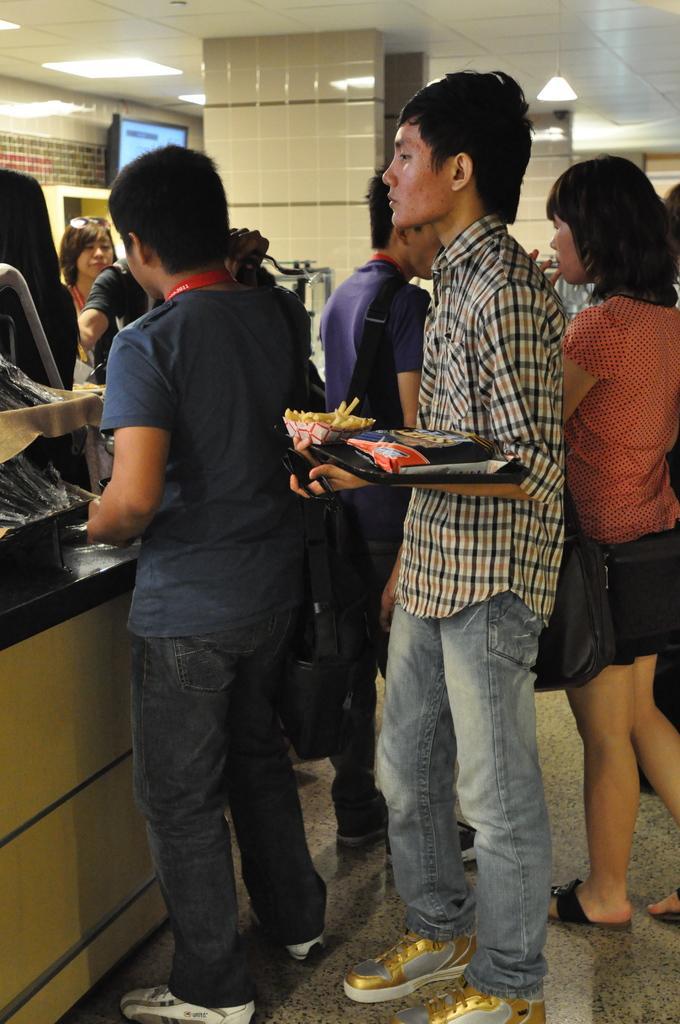Describe this image in one or two sentences. In this image we can see many people. One person is holding a packet. There are pillars. On the ceiling there are lights. Also there is a television near to the wall. 